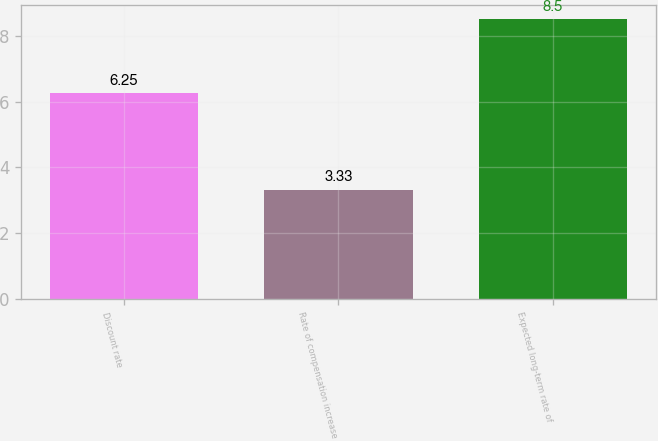<chart> <loc_0><loc_0><loc_500><loc_500><bar_chart><fcel>Discount rate<fcel>Rate of compensation increase<fcel>Expected long-term rate of<nl><fcel>6.25<fcel>3.33<fcel>8.5<nl></chart> 